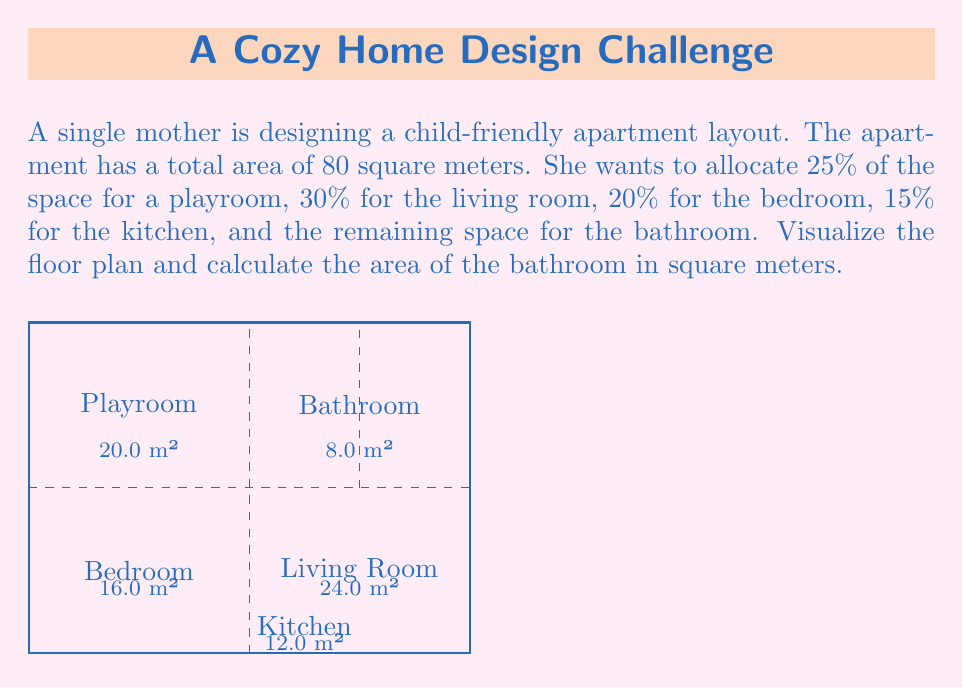Teach me how to tackle this problem. Let's approach this step-by-step:

1) First, let's calculate the areas allocated to each room:
   - Playroom: $25\% = 0.25 \times 80 = 20$ m²
   - Living room: $30\% = 0.30 \times 80 = 24$ m²
   - Bedroom: $20\% = 0.20 \times 80 = 16$ m²
   - Kitchen: $15\% = 0.15 \times 80 = 12$ m²

2) Now, let's add up these areas:
   $20 + 24 + 16 + 12 = 72$ m²

3) The total area of the apartment is 80 m². To find the bathroom area, we subtract the sum of the other rooms from the total:

   $\text{Bathroom area} = \text{Total area} - \text{Sum of other rooms}$
   $= 80 - 72 = 8$ m²

4) We can verify this by calculating the percentage:
   $\frac{8}{80} \times 100\% = 10\%$

   Indeed, this is the remaining percentage after allocating the other rooms.

The floor plan visualization shows how these rooms might be arranged in the apartment, with the bathroom occupying the smallest area in the top right corner.
Answer: 8 m² 